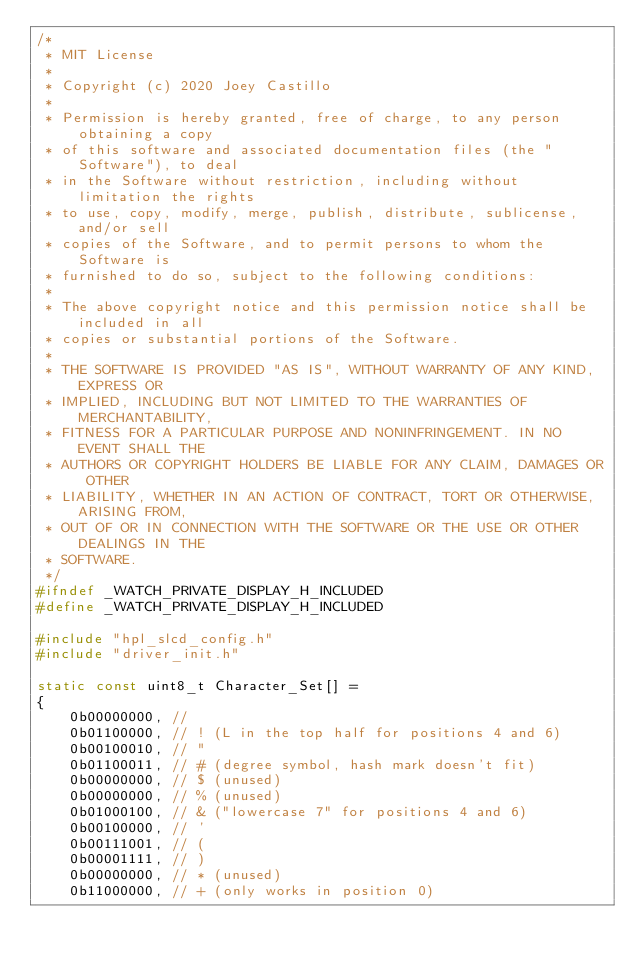Convert code to text. <code><loc_0><loc_0><loc_500><loc_500><_C_>/*
 * MIT License
 *
 * Copyright (c) 2020 Joey Castillo
 *
 * Permission is hereby granted, free of charge, to any person obtaining a copy
 * of this software and associated documentation files (the "Software"), to deal
 * in the Software without restriction, including without limitation the rights
 * to use, copy, modify, merge, publish, distribute, sublicense, and/or sell
 * copies of the Software, and to permit persons to whom the Software is
 * furnished to do so, subject to the following conditions:
 *
 * The above copyright notice and this permission notice shall be included in all
 * copies or substantial portions of the Software.
 *
 * THE SOFTWARE IS PROVIDED "AS IS", WITHOUT WARRANTY OF ANY KIND, EXPRESS OR
 * IMPLIED, INCLUDING BUT NOT LIMITED TO THE WARRANTIES OF MERCHANTABILITY,
 * FITNESS FOR A PARTICULAR PURPOSE AND NONINFRINGEMENT. IN NO EVENT SHALL THE
 * AUTHORS OR COPYRIGHT HOLDERS BE LIABLE FOR ANY CLAIM, DAMAGES OR OTHER
 * LIABILITY, WHETHER IN AN ACTION OF CONTRACT, TORT OR OTHERWISE, ARISING FROM,
 * OUT OF OR IN CONNECTION WITH THE SOFTWARE OR THE USE OR OTHER DEALINGS IN THE
 * SOFTWARE.
 */
#ifndef _WATCH_PRIVATE_DISPLAY_H_INCLUDED
#define _WATCH_PRIVATE_DISPLAY_H_INCLUDED

#include "hpl_slcd_config.h"
#include "driver_init.h"

static const uint8_t Character_Set[] =
{
    0b00000000, //  
    0b01100000, // ! (L in the top half for positions 4 and 6)
    0b00100010, // "
    0b01100011, // # (degree symbol, hash mark doesn't fit)
    0b00000000, // $ (unused)
    0b00000000, // % (unused)
    0b01000100, // & ("lowercase 7" for positions 4 and 6)
    0b00100000, // '
    0b00111001, // (
    0b00001111, // )
    0b00000000, // * (unused)
    0b11000000, // + (only works in position 0)</code> 